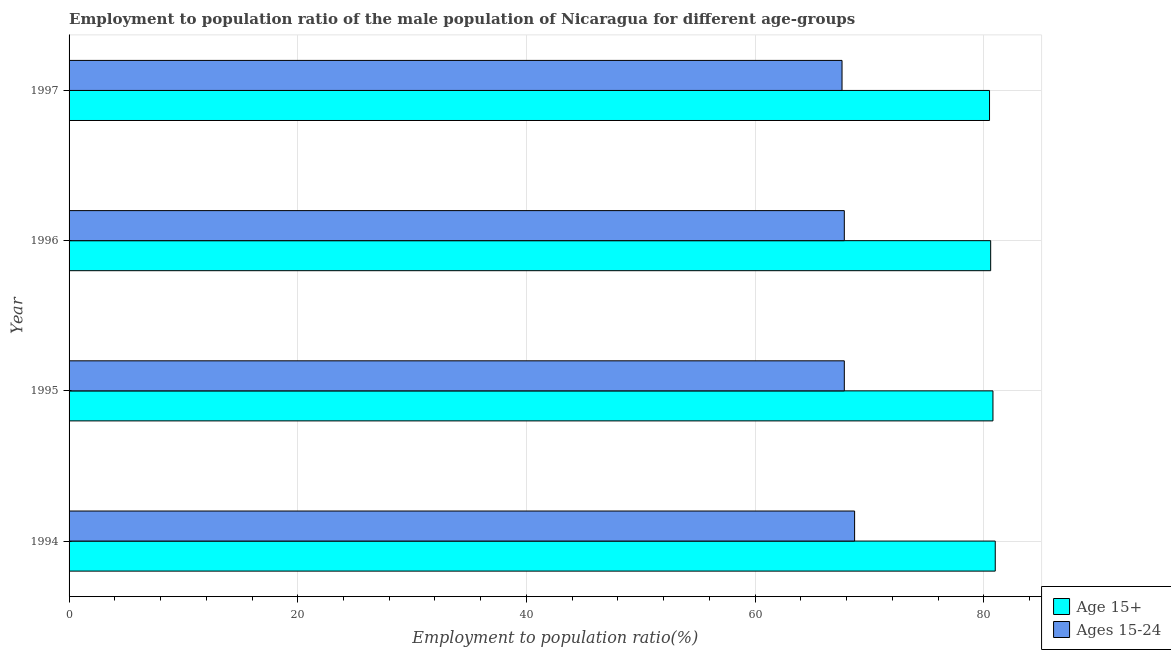Are the number of bars on each tick of the Y-axis equal?
Make the answer very short. Yes. In how many cases, is the number of bars for a given year not equal to the number of legend labels?
Ensure brevity in your answer.  0. What is the employment to population ratio(age 15+) in 1995?
Your answer should be compact. 80.8. Across all years, what is the minimum employment to population ratio(age 15+)?
Provide a short and direct response. 80.5. In which year was the employment to population ratio(age 15+) minimum?
Your response must be concise. 1997. What is the total employment to population ratio(age 15-24) in the graph?
Make the answer very short. 271.9. What is the difference between the employment to population ratio(age 15-24) in 1994 and that in 1995?
Make the answer very short. 0.9. What is the difference between the employment to population ratio(age 15+) in 1996 and the employment to population ratio(age 15-24) in 1997?
Ensure brevity in your answer.  13. What is the average employment to population ratio(age 15-24) per year?
Make the answer very short. 67.97. In the year 1997, what is the difference between the employment to population ratio(age 15+) and employment to population ratio(age 15-24)?
Offer a very short reply. 12.9. In how many years, is the employment to population ratio(age 15-24) greater than 16 %?
Your response must be concise. 4. What is the ratio of the employment to population ratio(age 15+) in 1995 to that in 1996?
Offer a terse response. 1. Is the employment to population ratio(age 15+) in 1994 less than that in 1997?
Ensure brevity in your answer.  No. Is the difference between the employment to population ratio(age 15-24) in 1996 and 1997 greater than the difference between the employment to population ratio(age 15+) in 1996 and 1997?
Your answer should be very brief. Yes. What is the difference between the highest and the second highest employment to population ratio(age 15+)?
Keep it short and to the point. 0.2. What does the 2nd bar from the top in 1996 represents?
Provide a short and direct response. Age 15+. What does the 2nd bar from the bottom in 1997 represents?
Offer a terse response. Ages 15-24. Are all the bars in the graph horizontal?
Give a very brief answer. Yes. How many years are there in the graph?
Provide a succinct answer. 4. Are the values on the major ticks of X-axis written in scientific E-notation?
Your answer should be compact. No. Where does the legend appear in the graph?
Provide a short and direct response. Bottom right. How are the legend labels stacked?
Provide a succinct answer. Vertical. What is the title of the graph?
Keep it short and to the point. Employment to population ratio of the male population of Nicaragua for different age-groups. What is the Employment to population ratio(%) in Ages 15-24 in 1994?
Offer a very short reply. 68.7. What is the Employment to population ratio(%) of Age 15+ in 1995?
Offer a very short reply. 80.8. What is the Employment to population ratio(%) in Ages 15-24 in 1995?
Ensure brevity in your answer.  67.8. What is the Employment to population ratio(%) in Age 15+ in 1996?
Provide a succinct answer. 80.6. What is the Employment to population ratio(%) of Ages 15-24 in 1996?
Ensure brevity in your answer.  67.8. What is the Employment to population ratio(%) in Age 15+ in 1997?
Offer a very short reply. 80.5. What is the Employment to population ratio(%) in Ages 15-24 in 1997?
Ensure brevity in your answer.  67.6. Across all years, what is the maximum Employment to population ratio(%) of Age 15+?
Keep it short and to the point. 81. Across all years, what is the maximum Employment to population ratio(%) of Ages 15-24?
Provide a short and direct response. 68.7. Across all years, what is the minimum Employment to population ratio(%) in Age 15+?
Offer a terse response. 80.5. Across all years, what is the minimum Employment to population ratio(%) in Ages 15-24?
Ensure brevity in your answer.  67.6. What is the total Employment to population ratio(%) of Age 15+ in the graph?
Offer a terse response. 322.9. What is the total Employment to population ratio(%) in Ages 15-24 in the graph?
Your response must be concise. 271.9. What is the difference between the Employment to population ratio(%) of Ages 15-24 in 1994 and that in 1995?
Provide a succinct answer. 0.9. What is the difference between the Employment to population ratio(%) of Age 15+ in 1994 and that in 1997?
Offer a terse response. 0.5. What is the difference between the Employment to population ratio(%) in Age 15+ in 1995 and that in 1996?
Provide a succinct answer. 0.2. What is the difference between the Employment to population ratio(%) in Ages 15-24 in 1995 and that in 1996?
Your answer should be very brief. 0. What is the difference between the Employment to population ratio(%) of Ages 15-24 in 1996 and that in 1997?
Offer a very short reply. 0.2. What is the average Employment to population ratio(%) of Age 15+ per year?
Ensure brevity in your answer.  80.72. What is the average Employment to population ratio(%) of Ages 15-24 per year?
Make the answer very short. 67.97. What is the ratio of the Employment to population ratio(%) in Ages 15-24 in 1994 to that in 1995?
Provide a succinct answer. 1.01. What is the ratio of the Employment to population ratio(%) in Age 15+ in 1994 to that in 1996?
Keep it short and to the point. 1. What is the ratio of the Employment to population ratio(%) of Ages 15-24 in 1994 to that in 1996?
Your answer should be very brief. 1.01. What is the ratio of the Employment to population ratio(%) in Age 15+ in 1994 to that in 1997?
Ensure brevity in your answer.  1.01. What is the ratio of the Employment to population ratio(%) of Ages 15-24 in 1994 to that in 1997?
Ensure brevity in your answer.  1.02. What is the ratio of the Employment to population ratio(%) in Age 15+ in 1995 to that in 1996?
Provide a succinct answer. 1. What is the ratio of the Employment to population ratio(%) in Age 15+ in 1995 to that in 1997?
Your answer should be compact. 1. What is the difference between the highest and the second highest Employment to population ratio(%) in Age 15+?
Your answer should be very brief. 0.2. What is the difference between the highest and the second highest Employment to population ratio(%) of Ages 15-24?
Keep it short and to the point. 0.9. What is the difference between the highest and the lowest Employment to population ratio(%) of Age 15+?
Offer a terse response. 0.5. 